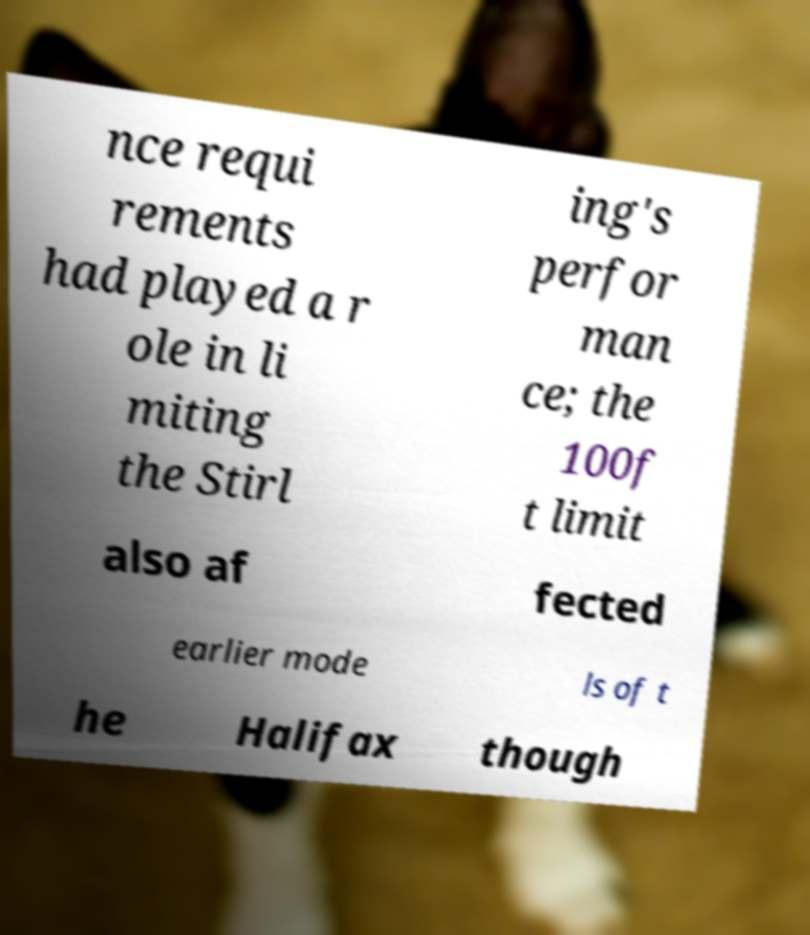Could you assist in decoding the text presented in this image and type it out clearly? nce requi rements had played a r ole in li miting the Stirl ing's perfor man ce; the 100f t limit also af fected earlier mode ls of t he Halifax though 